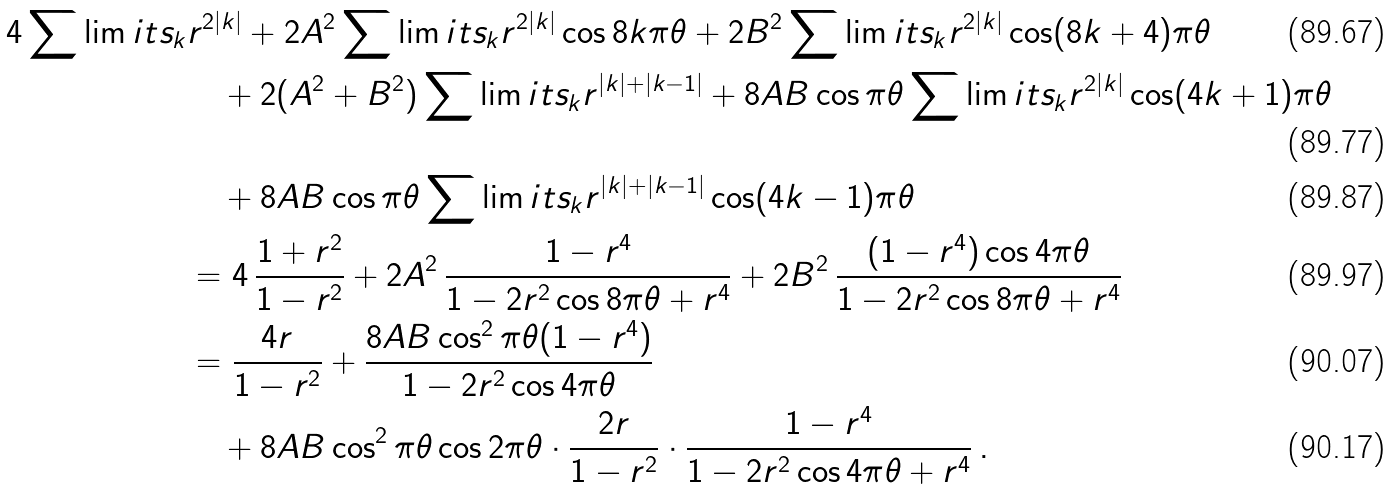<formula> <loc_0><loc_0><loc_500><loc_500>4 \sum \lim i t s _ { k } & r ^ { 2 | k | } + 2 A ^ { 2 } \sum \lim i t s _ { k } r ^ { 2 | k | } \cos 8 k \pi \theta + 2 B ^ { 2 } \sum \lim i t s _ { k } r ^ { 2 | k | } \cos ( 8 k + 4 ) \pi \theta \\ & \quad + 2 ( A ^ { 2 } + B ^ { 2 } ) \sum \lim i t s _ { k } r ^ { | k | + | k - 1 | } + 8 A B \cos \pi \theta \sum \lim i t s _ { k } r ^ { 2 | k | } \cos ( 4 k + 1 ) \pi \theta \\ & \quad + 8 A B \cos \pi \theta \sum \lim i t s _ { k } r ^ { | k | + | k - 1 | } \cos ( 4 k - 1 ) \pi \theta \\ & = 4 \, \frac { 1 + r ^ { 2 } } { 1 - r ^ { 2 } } + 2 A ^ { 2 } \, \frac { 1 - r ^ { 4 } } { 1 - 2 r ^ { 2 } \cos 8 \pi \theta + r ^ { 4 } } + 2 B ^ { 2 } \, \frac { ( 1 - r ^ { 4 } ) \cos 4 \pi \theta } { 1 - 2 r ^ { 2 } \cos 8 \pi \theta + r ^ { 4 } } \\ & = \frac { 4 r } { 1 - r ^ { 2 } } + \frac { 8 A B \cos ^ { 2 } \pi \theta ( 1 - r ^ { 4 } ) } { 1 - 2 r ^ { 2 } \cos 4 \pi \theta } \\ & \quad + 8 A B \cos ^ { 2 } \pi \theta \cos 2 \pi \theta \cdot \frac { 2 r } { 1 - r ^ { 2 } } \cdot \frac { 1 - r ^ { 4 } } { 1 - 2 r ^ { 2 } \cos 4 \pi \theta + r ^ { 4 } } \, .</formula> 